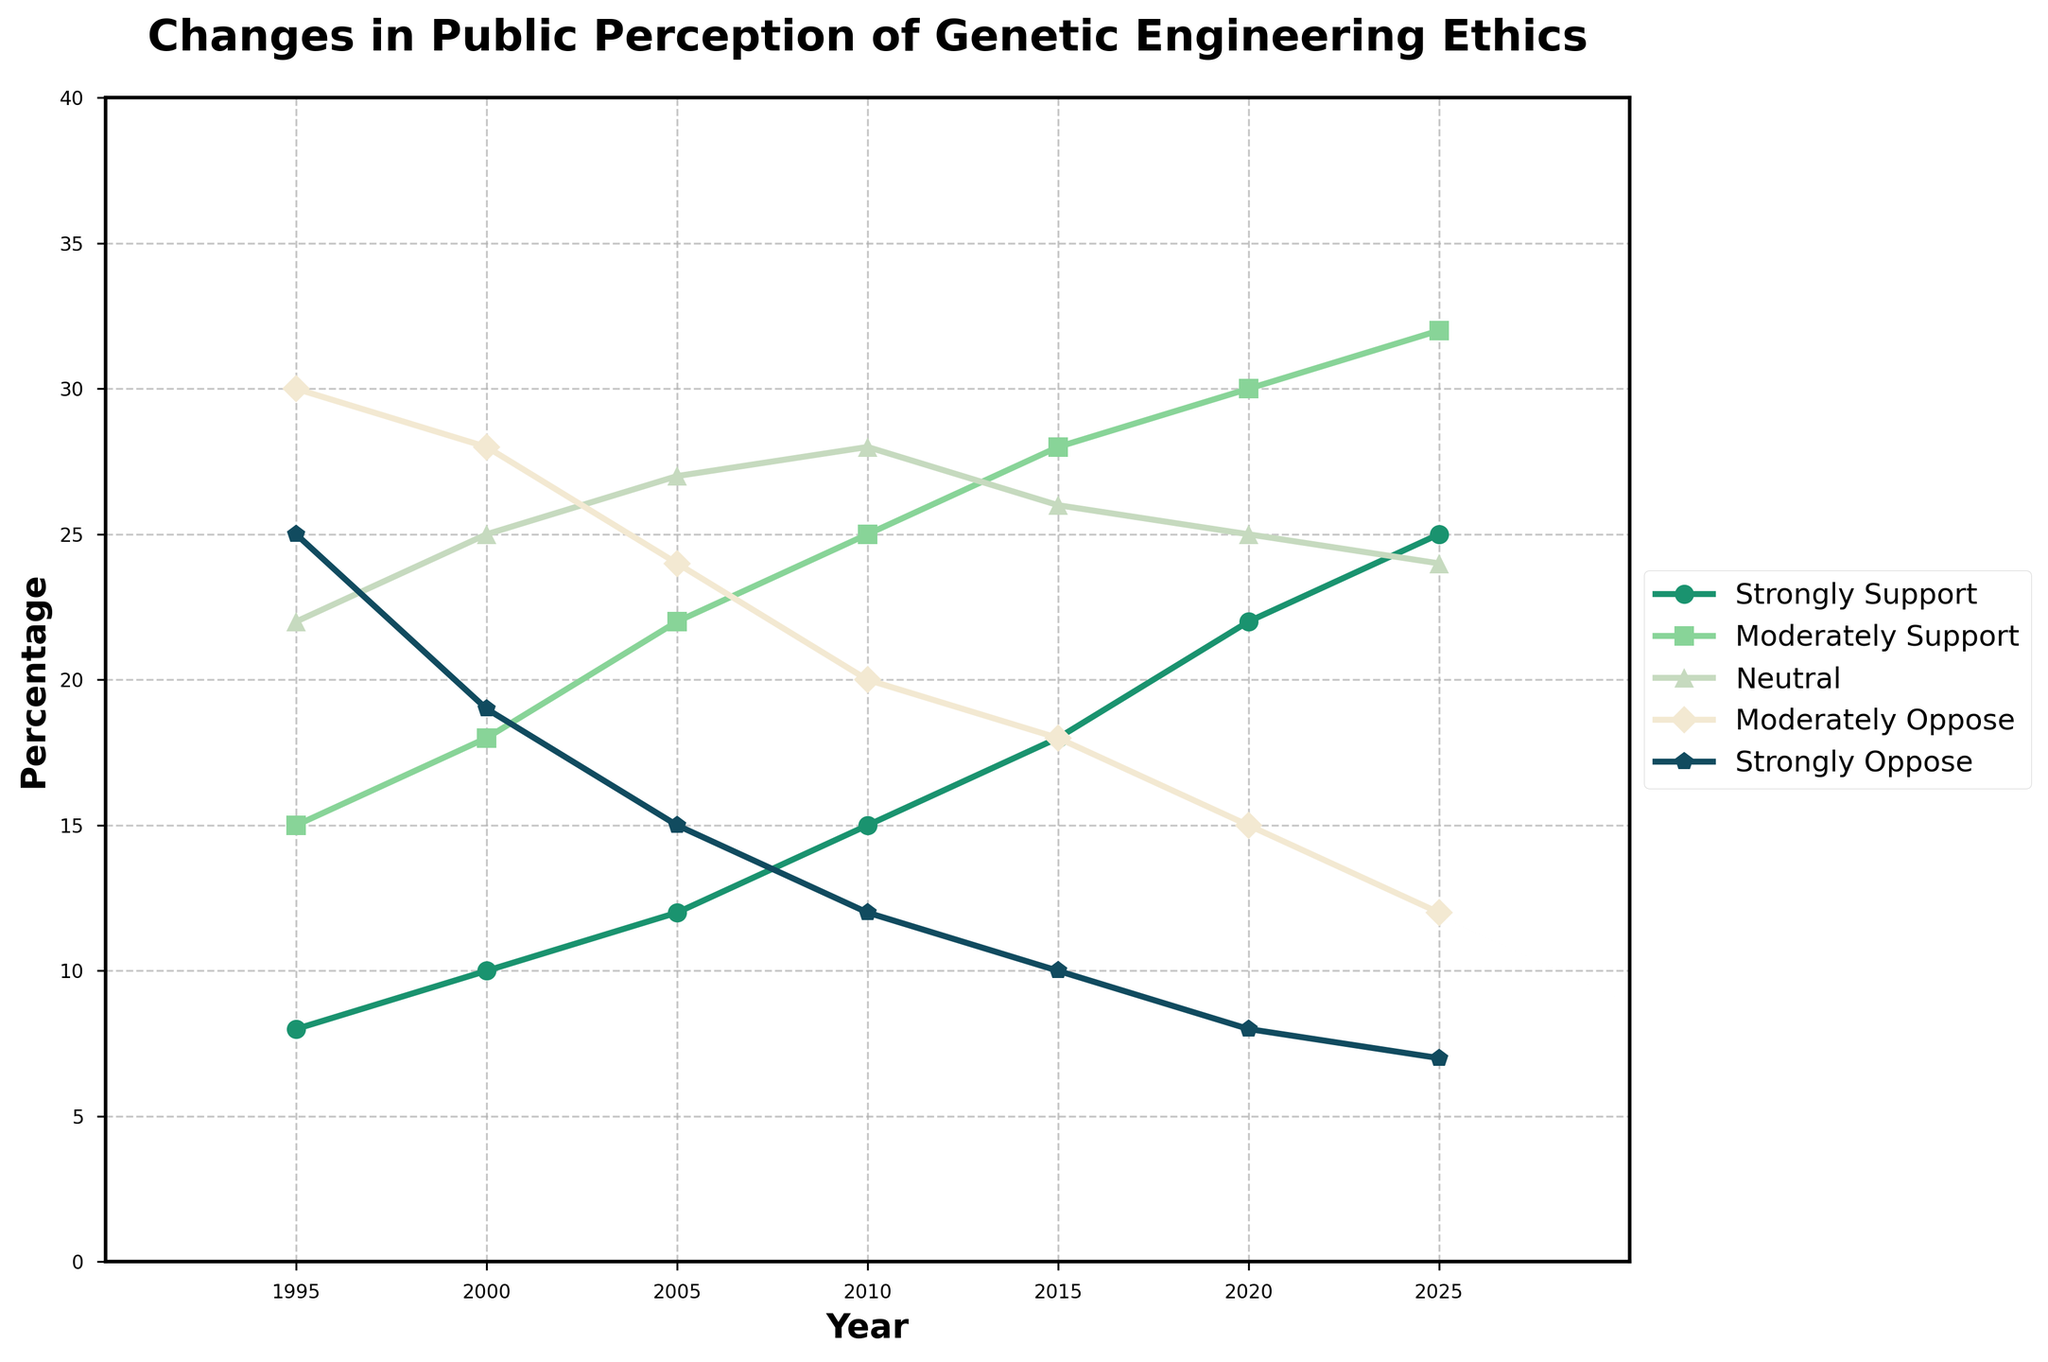What year shows the highest percentage of people who strongly support genetic engineering? By examining the line representing "Strongly Support," the highest point is at 2025, with a value of 25%.
Answer: 2025 Comparing 1995 to 2025, how has the percentage of people who strongly oppose genetic engineering changed? In 1995, the "Strongly Oppose" percentage is 25%. By 2025, it decreases to 7%. The change is 25% - 7% = 18%.
Answer: Decreased by 18% Which category shows the most significant increase from 1995 to 2025? Each category's values for 1995 and 2025 are: 
- Strongly Support: 8% -> 25% (increase of 17%)
- Moderately Support: 15% -> 32% (increase of 17%)
Comparing these increases, both "Strongly Support" and "Moderately Support" increased by 17%, which is the highest.
Answer: Strongly Support and Moderately Support If you combine the percentages of people who are neutral or moderately support genetic engineering in 2010, what is the total? In 2010, "Neutral" is 28% and "Moderately Support" is 25%. Summing them results in 28 + 25 = 53%.
Answer: 53% What is the overall trend for people who moderately oppose genetic engineering over time? The "Moderately Oppose" line shows a consistent decline from 30% in 1995 to 12% in 2025.
Answer: Decreasing trend Between 2000 and 2020, how has the percentage of people who are neutral changed? In 2000, the "Neutral" percentage is 25%. By 2020, it is 25%. This indicates no change over the given period.
Answer: No change How does the percentage of people who moderately support genetic engineering in 2005 compare to those who moderately oppose it in the same year? In 2005, "Moderately Support" is 22% and "Moderately Oppose" is 24%. Hence, moderately support is less than moderately oppose by 2%.
Answer: Moderately Support is 2% less What is the percentage difference between people who strongly support and those who strongly oppose genetic engineering in 2020? In 2020, "Strongly Support" is 22% and "Strongly Oppose" is 8%. The difference is 22% - 8% = 14%.
Answer: 14% What year represents the crossover point where the percentage of those who strongly support surpasses those who strongly oppose? Observing the two lines, the crossover occurs between 2005 and 2010 when "Strongly Support" surpasses "Strongly Oppose".
Answer: Between 2005 and 2010 How did the percentage of people who moderately oppose genetic engineering change between 2005 and 2015? In 2005, "Moderately Oppose" is 24% and in 2015 it is 18%. The change is 24% - 18% = 6%.
Answer: Decreased by 6% 